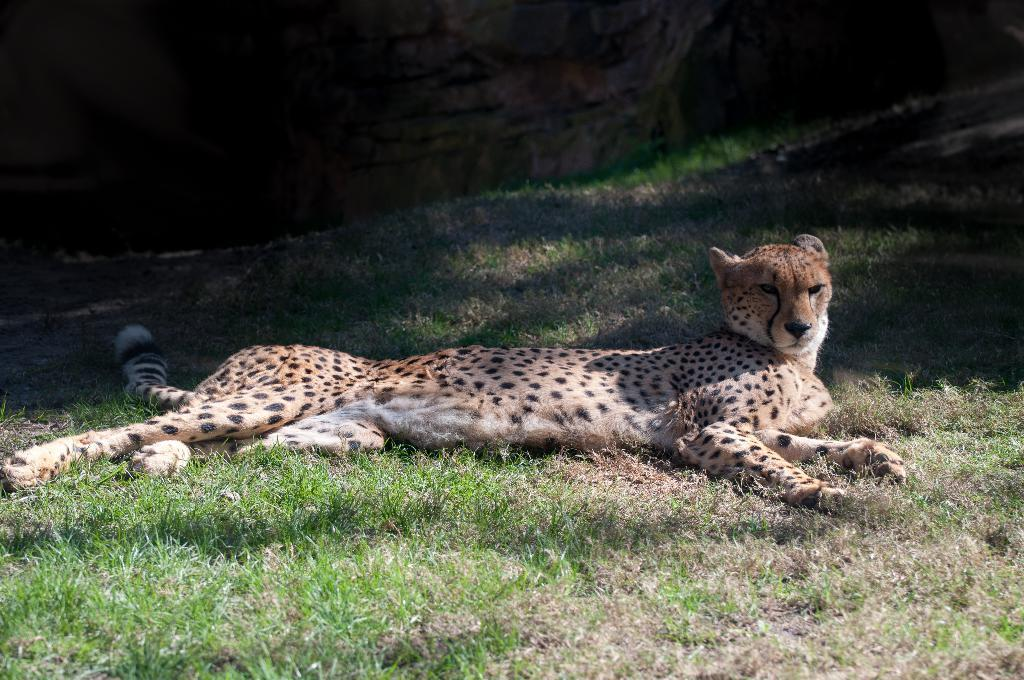What animal is present in the image? There is a cheetah in the image. What is the cheetah doing in the image? The cheetah is sleeping in the image. Where is the cheetah located in the image? The cheetah is on the ground in the image. What type of wrench is the cheetah using to create harmony in the image? There is no wrench or any indication of creating harmony present in the image; it features a sleeping cheetah on the ground. 